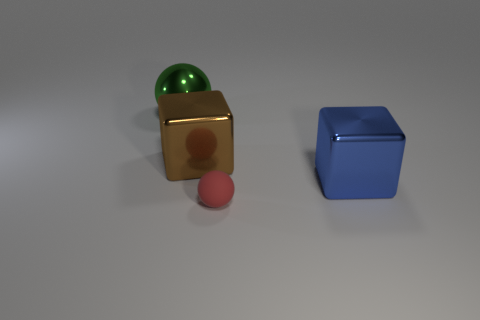Add 2 tiny balls. How many objects exist? 6 Add 3 blue shiny things. How many blue shiny things are left? 4 Add 4 blue cubes. How many blue cubes exist? 5 Subtract 1 green balls. How many objects are left? 3 Subtract all large balls. Subtract all big brown shiny things. How many objects are left? 2 